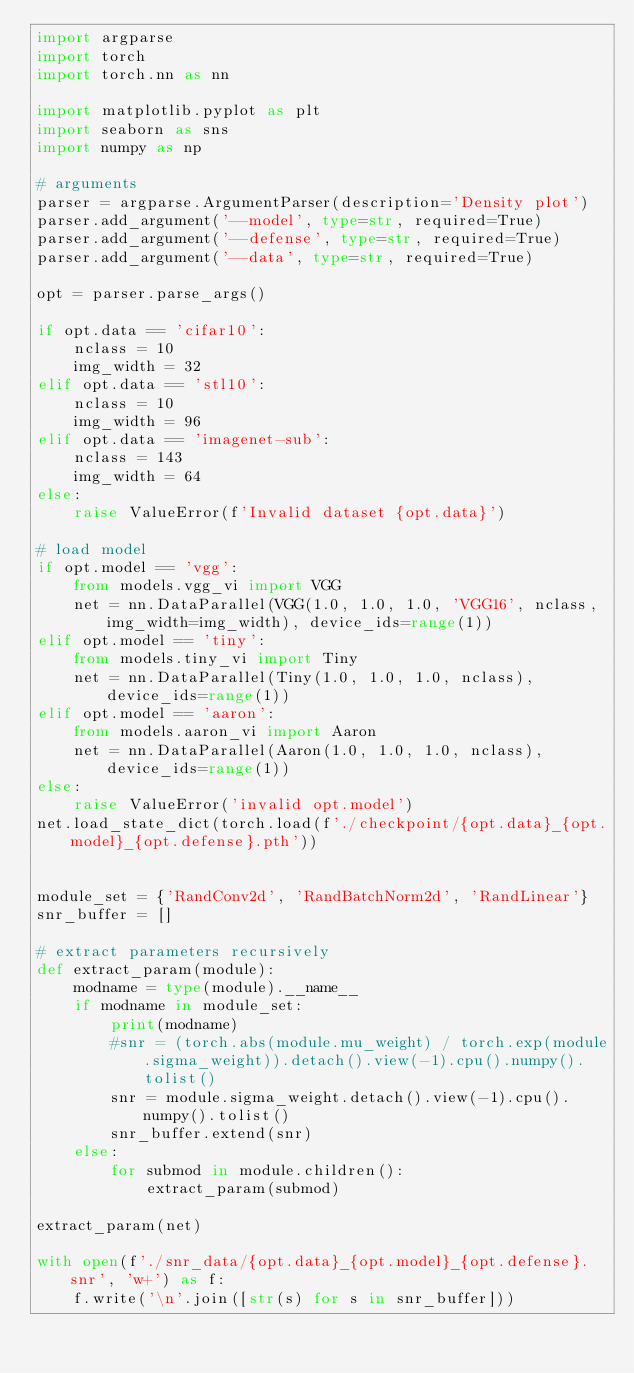Convert code to text. <code><loc_0><loc_0><loc_500><loc_500><_Python_>import argparse
import torch
import torch.nn as nn

import matplotlib.pyplot as plt
import seaborn as sns
import numpy as np

# arguments
parser = argparse.ArgumentParser(description='Density plot')
parser.add_argument('--model', type=str, required=True)
parser.add_argument('--defense', type=str, required=True)
parser.add_argument('--data', type=str, required=True)

opt = parser.parse_args()

if opt.data == 'cifar10':
    nclass = 10
    img_width = 32
elif opt.data == 'stl10':
    nclass = 10
    img_width = 96
elif opt.data == 'imagenet-sub':
    nclass = 143
    img_width = 64
else:
    raise ValueError(f'Invalid dataset {opt.data}')

# load model
if opt.model == 'vgg':
    from models.vgg_vi import VGG
    net = nn.DataParallel(VGG(1.0, 1.0, 1.0, 'VGG16', nclass, img_width=img_width), device_ids=range(1))
elif opt.model == 'tiny':
    from models.tiny_vi import Tiny
    net = nn.DataParallel(Tiny(1.0, 1.0, 1.0, nclass), device_ids=range(1))
elif opt.model == 'aaron':
    from models.aaron_vi import Aaron
    net = nn.DataParallel(Aaron(1.0, 1.0, 1.0, nclass), device_ids=range(1))
else:
    raise ValueError('invalid opt.model')
net.load_state_dict(torch.load(f'./checkpoint/{opt.data}_{opt.model}_{opt.defense}.pth'))


module_set = {'RandConv2d', 'RandBatchNorm2d', 'RandLinear'}
snr_buffer = []

# extract parameters recursively
def extract_param(module):
    modname = type(module).__name__
    if modname in module_set:
        print(modname)
        #snr = (torch.abs(module.mu_weight) / torch.exp(module.sigma_weight)).detach().view(-1).cpu().numpy().tolist()
        snr = module.sigma_weight.detach().view(-1).cpu().numpy().tolist()
        snr_buffer.extend(snr)
    else:
        for submod in module.children():
            extract_param(submod)

extract_param(net)

with open(f'./snr_data/{opt.data}_{opt.model}_{opt.defense}.snr', 'w+') as f:
    f.write('\n'.join([str(s) for s in snr_buffer]))
</code> 